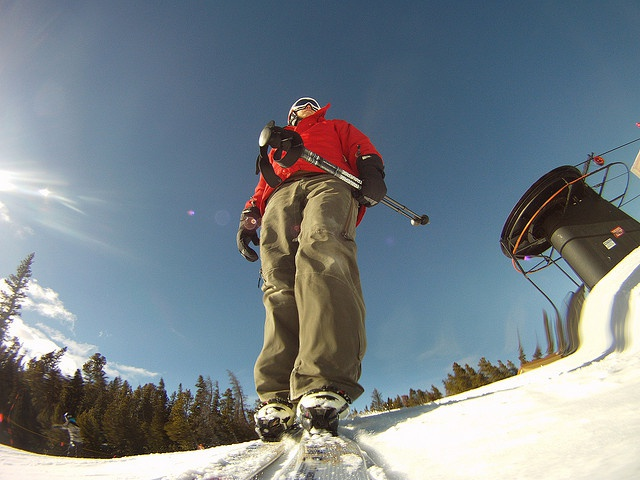Describe the objects in this image and their specific colors. I can see people in gray, black, maroon, and tan tones, skis in gray, beige, darkgray, and tan tones, and people in gray, black, and olive tones in this image. 